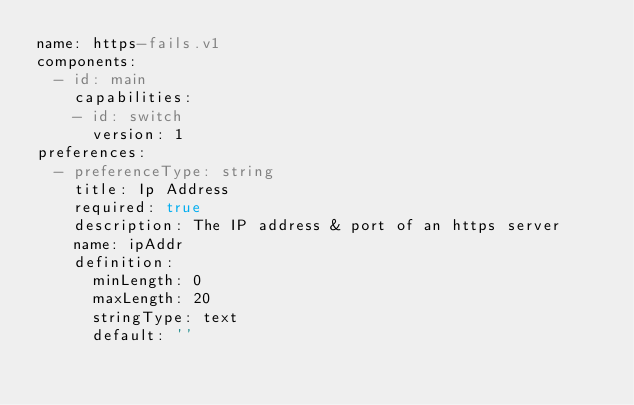Convert code to text. <code><loc_0><loc_0><loc_500><loc_500><_YAML_>name: https-fails.v1
components:
  - id: main
    capabilities:
    - id: switch
      version: 1
preferences:
  - preferenceType: string
    title: Ip Address
    required: true
    description: The IP address & port of an https server
    name: ipAddr
    definition:
      minLength: 0
      maxLength: 20
      stringType: text
      default: ''
</code> 